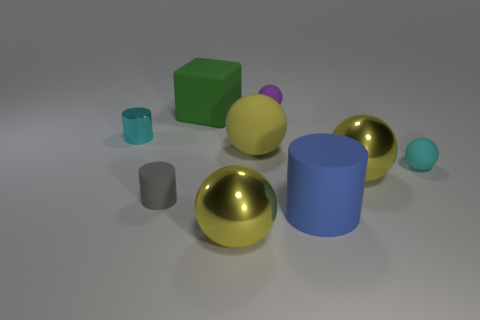How many objects are there and can you describe their arrangement with respect to each other? There are seven objects in total, strategically placed to create a balanced composition. Two large gold spheres dominate the foreground, while a deep blue cylinder, a green cube, and a violet sphere with a small blue cap form a mid-ground cluster. In the background, a smaller teal cylinder and a tiny turquoise sphere quietly complement the ensemble. 